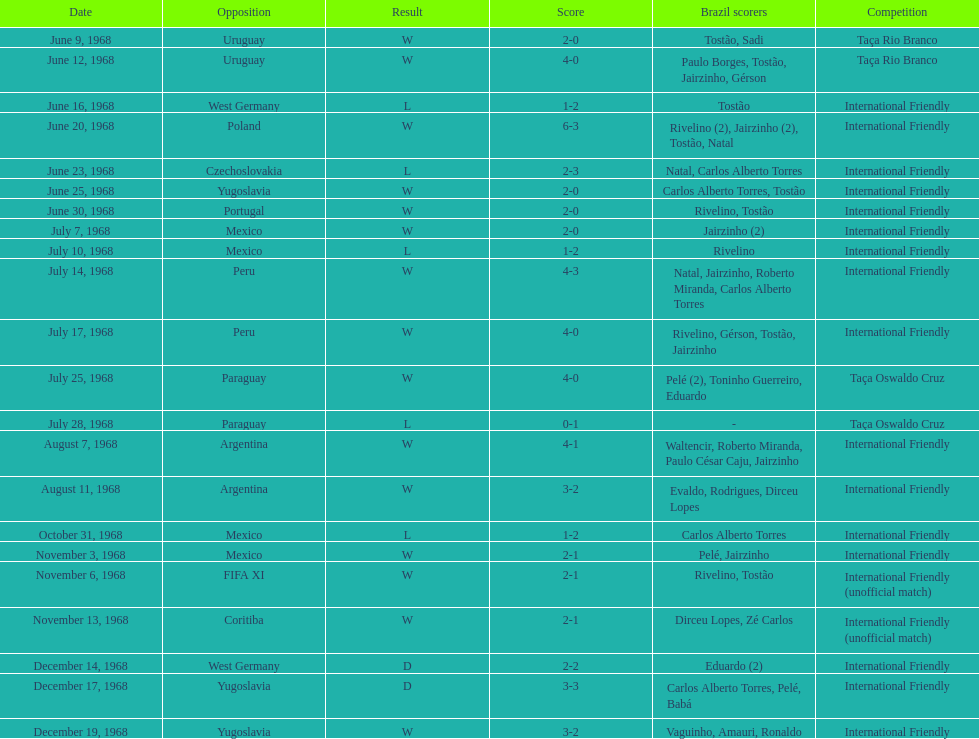How many games are victories? 15. 